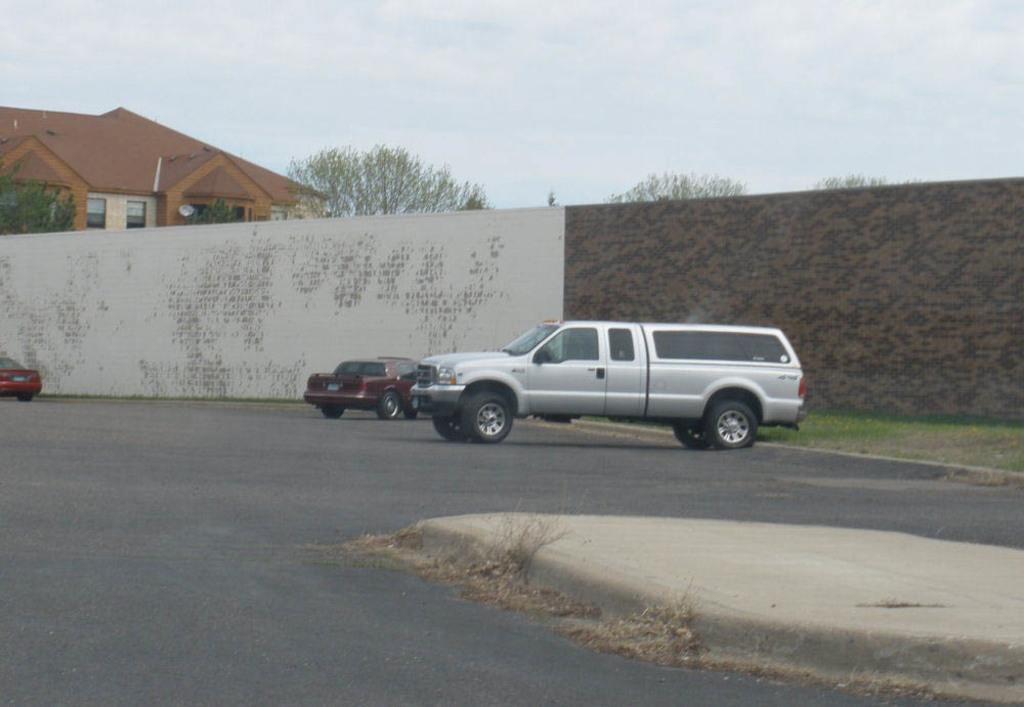In one or two sentences, can you explain what this image depicts? It is a car on the road, this is the wall. On the left side there is a house. At the top it is the sky. 